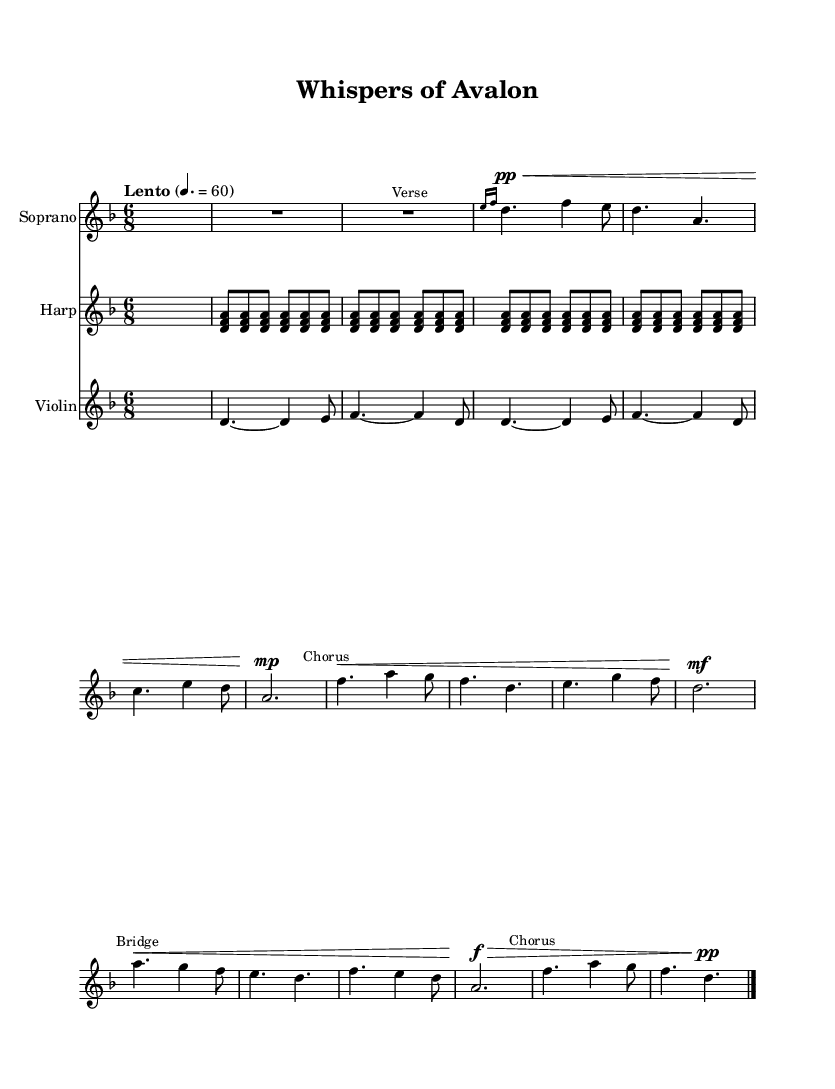What is the key signature of this music? The key signature is indicated by the sharp or flat symbols at the beginning of the staff. This piece has no sharps or flats shown, which indicates it is in D minor.
Answer: D minor What is the time signature of this music? The time signature is shown at the beginning of the piece and is represented as a fraction. Here, it is 6/8, meaning there are six eighth notes in each measure.
Answer: 6/8 What is the tempo marking of this piece? The tempo is noted above the staff as "Lento" with a metronome marking of 60, indicating a slow tempo.
Answer: Lento How many measures are in the chorus section? To find the number of measures in the chorus, we look at the section labeled "Chorus" and count the measures that fall under it. There are 2 full measures noted here.
Answer: 2 What dynamic marking is used in the bridge section? The dynamic marking indicates the volume at which the music should be played. In the bridge section, the marking is "f" which stands for forte, indicating to play loudly.
Answer: forte Is there a grace note in the first verse? There is a grace note in the first verse, which is indicated by the notation before the main note. Here, an e grace note is represented before playing the d note.
Answer: Yes What instruments are featured in this sheet music? The instruments are listed at the beginning of each staff and include a soprano voice, a harp, and a violin.
Answer: Soprano, harp, violin 